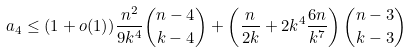<formula> <loc_0><loc_0><loc_500><loc_500>a _ { 4 } \leq ( 1 + o ( 1 ) ) \frac { n ^ { 2 } } { 9 k ^ { 4 } } { { n - 4 } \choose { k - 4 } } + \left ( \frac { n } { 2 k } + 2 k ^ { 4 } \frac { 6 n } { k ^ { 7 } } \right ) { { n - 3 } \choose { k - 3 } }</formula> 